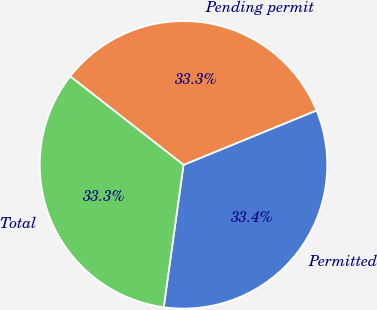Convert chart to OTSL. <chart><loc_0><loc_0><loc_500><loc_500><pie_chart><fcel>Permitted<fcel>Pending permit<fcel>Total<nl><fcel>33.38%<fcel>33.27%<fcel>33.35%<nl></chart> 